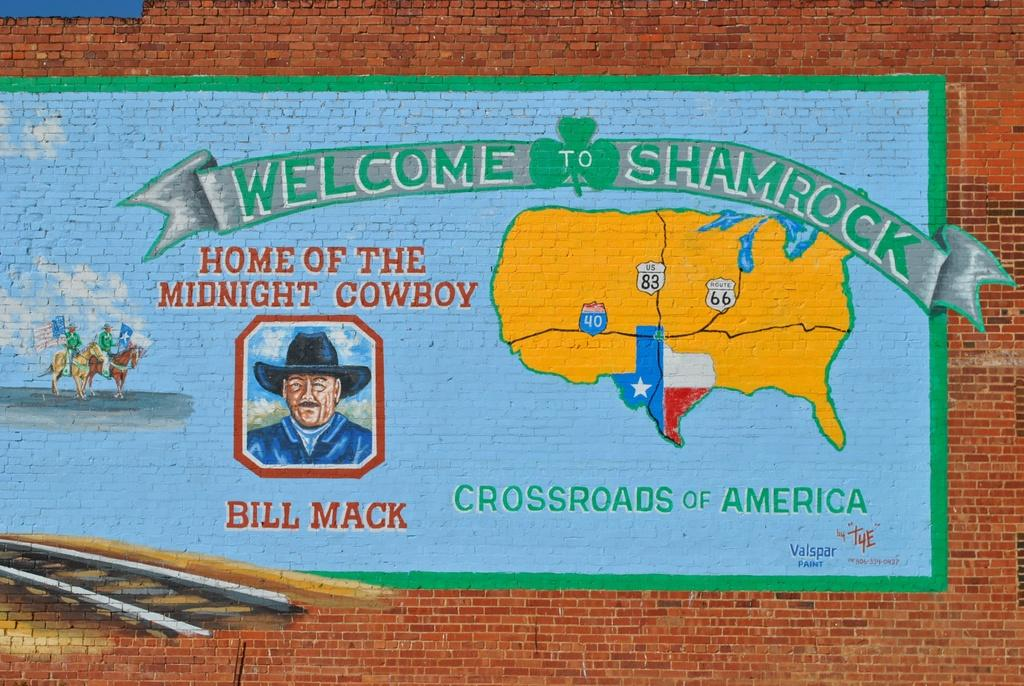What can be seen on the wall in the image? There is a painting on the wall in the image. What elements are included in the painting? The painting contains images and text. How many girls can be seen walking down the road in the image? There are no girls or roads present in the image; it features a wall with a painting on it. What type of pipe is visible in the image? There is no pipe present in the image. 